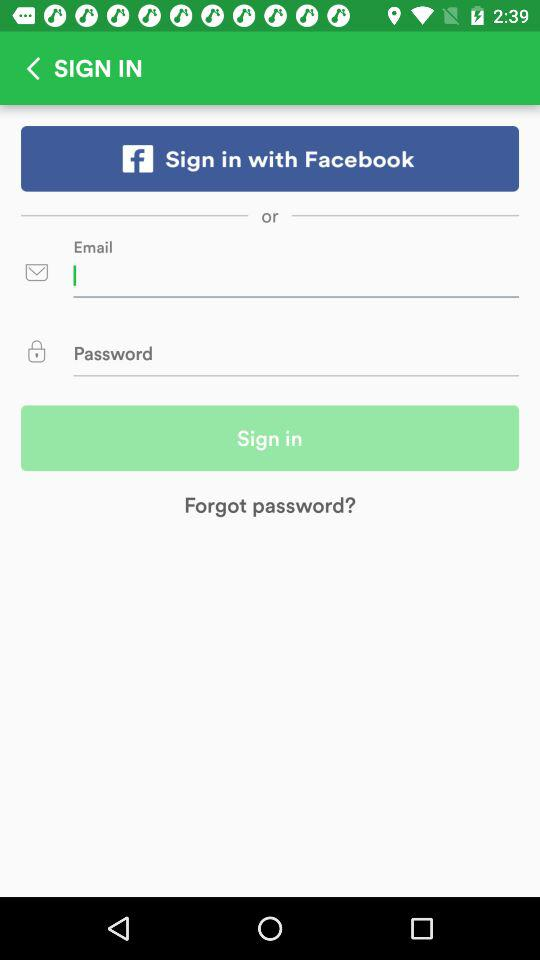Through what social media account can signing in be done? Signing in can be done through "Facebook". 